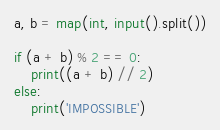<code> <loc_0><loc_0><loc_500><loc_500><_Python_>a, b = map(int, input().split())

if (a + b) % 2 == 0:
    print((a + b) // 2)
else:
    print('IMPOSSIBLE') </code> 